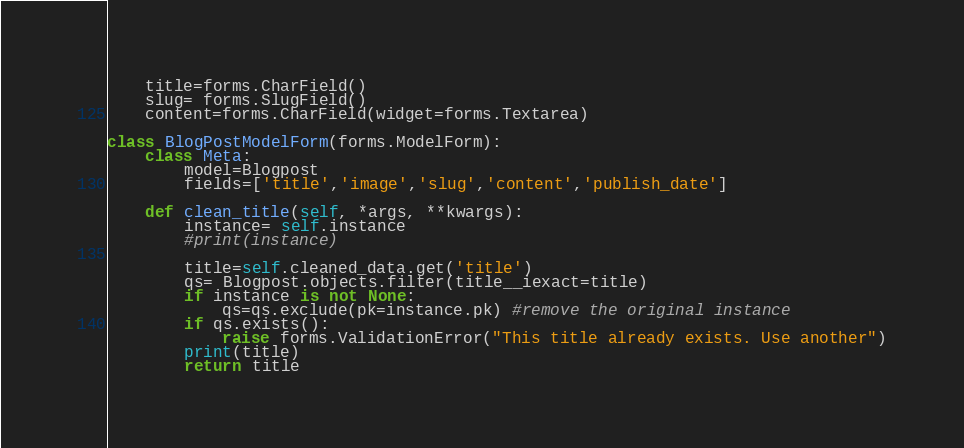Convert code to text. <code><loc_0><loc_0><loc_500><loc_500><_Python_>	title=forms.CharField()
	slug= forms.SlugField()
	content=forms.CharField(widget=forms.Textarea)

class BlogPostModelForm(forms.ModelForm):
 	class Meta:
 		model=Blogpost
 		fields=['title','image','slug','content','publish_date']

 	def clean_title(self, *args, **kwargs):
 		instance= self.instance
 		#print(instance)

 		title=self.cleaned_data.get('title')
 		qs= Blogpost.objects.filter(title__iexact=title)
 		if instance is not None:
 			qs=qs.exclude(pk=instance.pk) #remove the original instance
 		if qs.exists():
 			raise forms.ValidationError("This title already exists. Use another")
 		print(title)
 		return title
</code> 